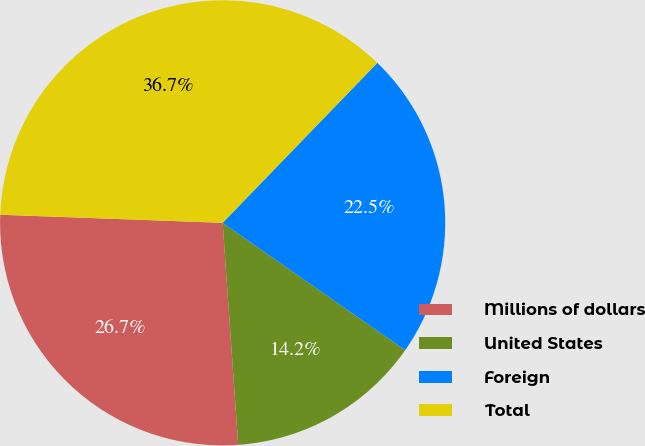Convert chart to OTSL. <chart><loc_0><loc_0><loc_500><loc_500><pie_chart><fcel>Millions of dollars<fcel>United States<fcel>Foreign<fcel>Total<nl><fcel>26.69%<fcel>14.19%<fcel>22.46%<fcel>36.65%<nl></chart> 